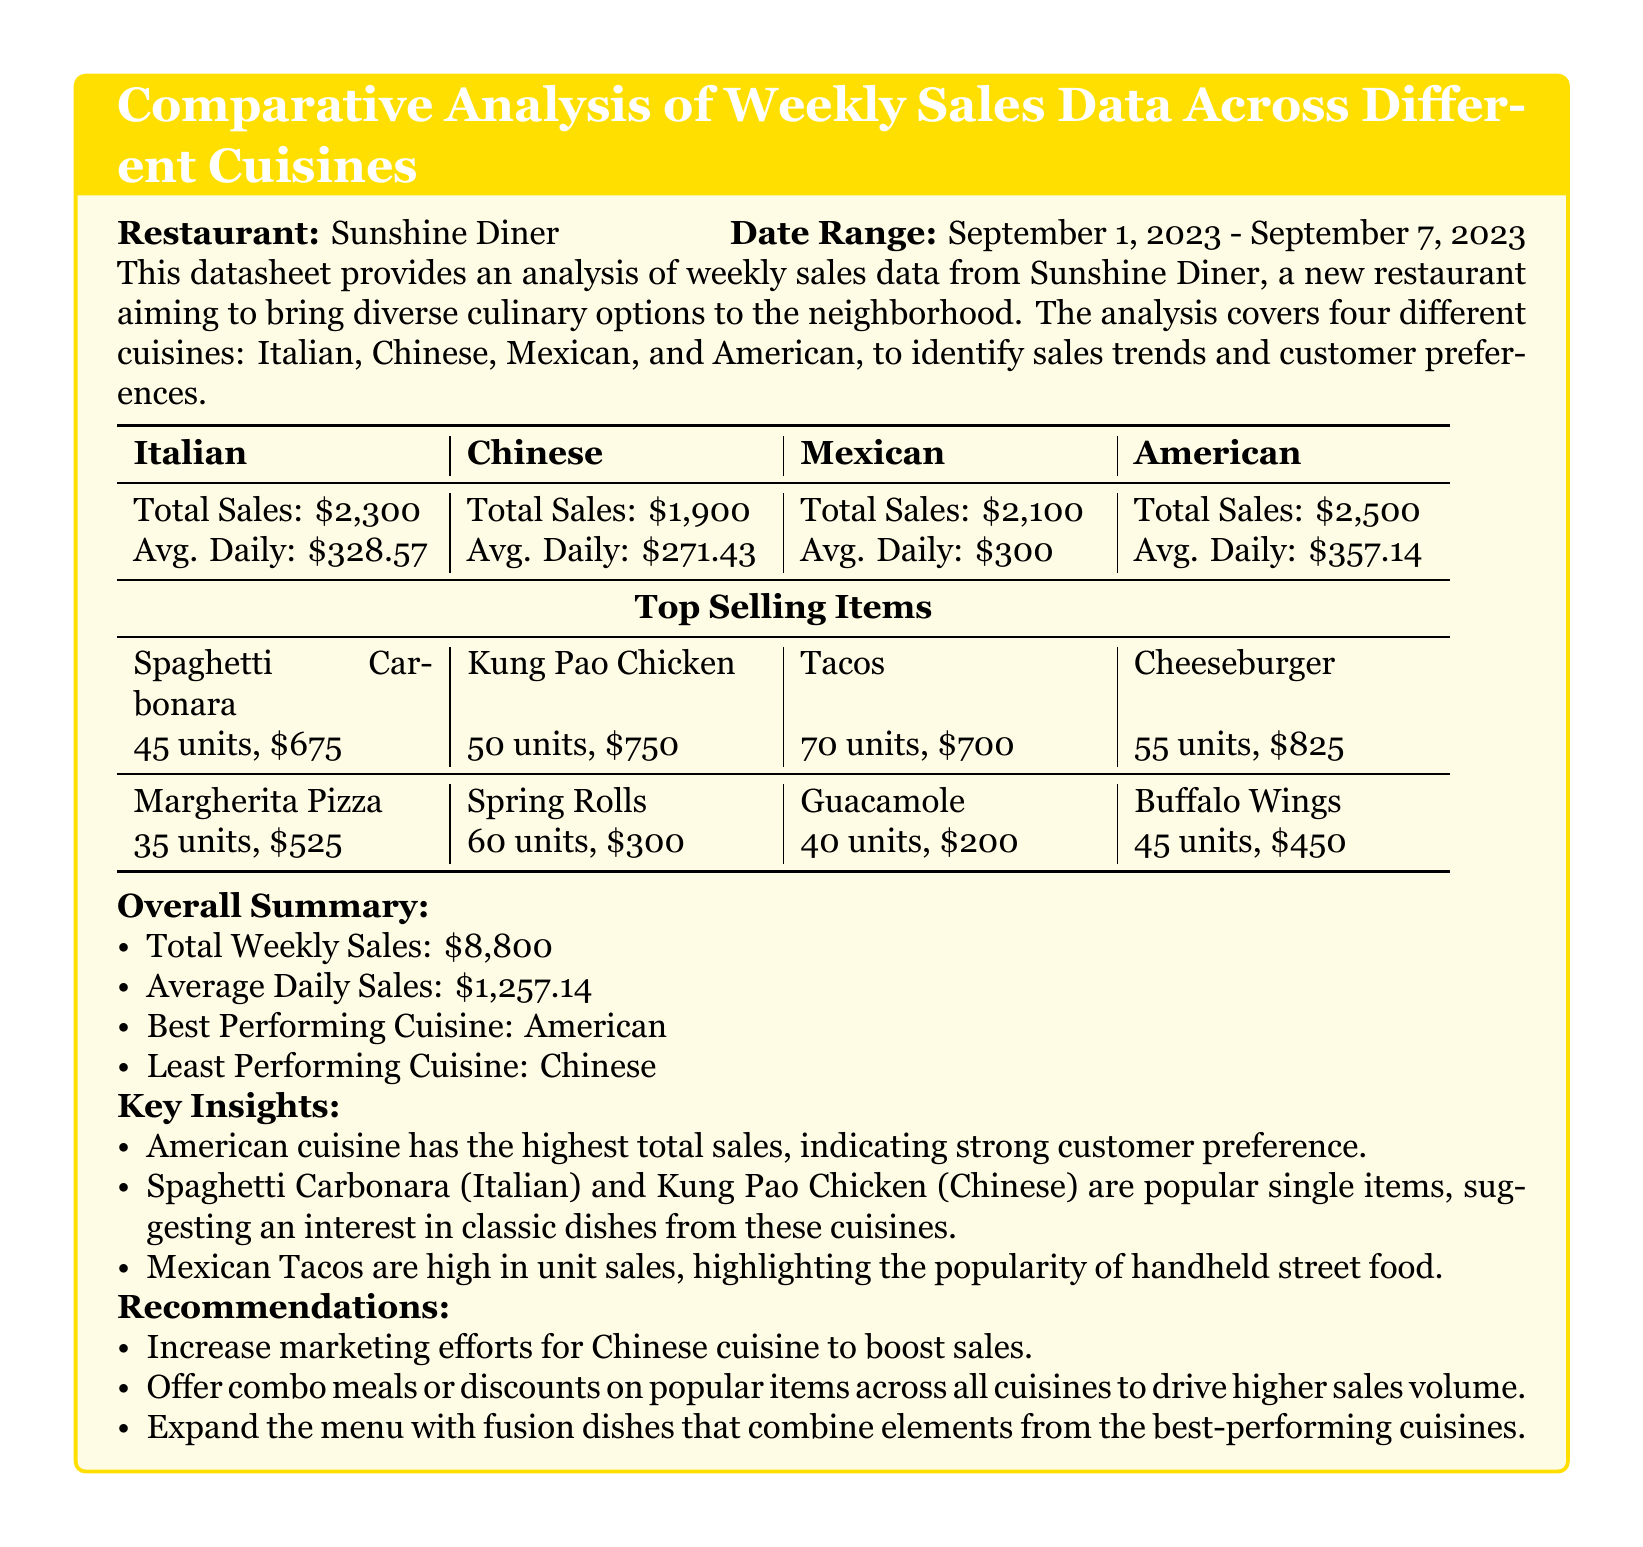What is the total sales for American cuisine? The total sales for American cuisine is directly stated in the table.
Answer: \$2,500 What is the average daily sales for Italian cuisine? The average daily sales for Italian cuisine is provided in the document under the Italian section.
Answer: \$328.57 Which cuisine had the least total sales? The document explicitly indicates the least performing cuisine in the summary section.
Answer: Chinese How many units of Tacos were sold? The document lists the top-selling items for each cuisine, including the number of Tacos sold.
Answer: 70 units What was the total weekly sales across all cuisines? The total weekly sales is provided in the overall summary section of the document.
Answer: \$8,800 Which item sold the highest in terms of revenue from American cuisine? The document specifies the top-selling item for American cuisine and its revenue.
Answer: Cheeseburger What is the average daily sales across all cuisines? The average daily sales is summarized at the end of the datasheet and is derived from the total weekly sales.
Answer: \$1,257.14 What recommendation is given to boost sales for Chinese cuisine? The recommendations section explicitly mentions actions to improve Chinese cuisine sales.
Answer: Increase marketing efforts Which cuisine is noted as the best performing? The overall summary clearly states the best performing cuisine based on total sales.
Answer: American How many units of Kung Pao Chicken were sold? The document provides the sales information for Kung Pao Chicken in the top-selling items list.
Answer: 50 units 